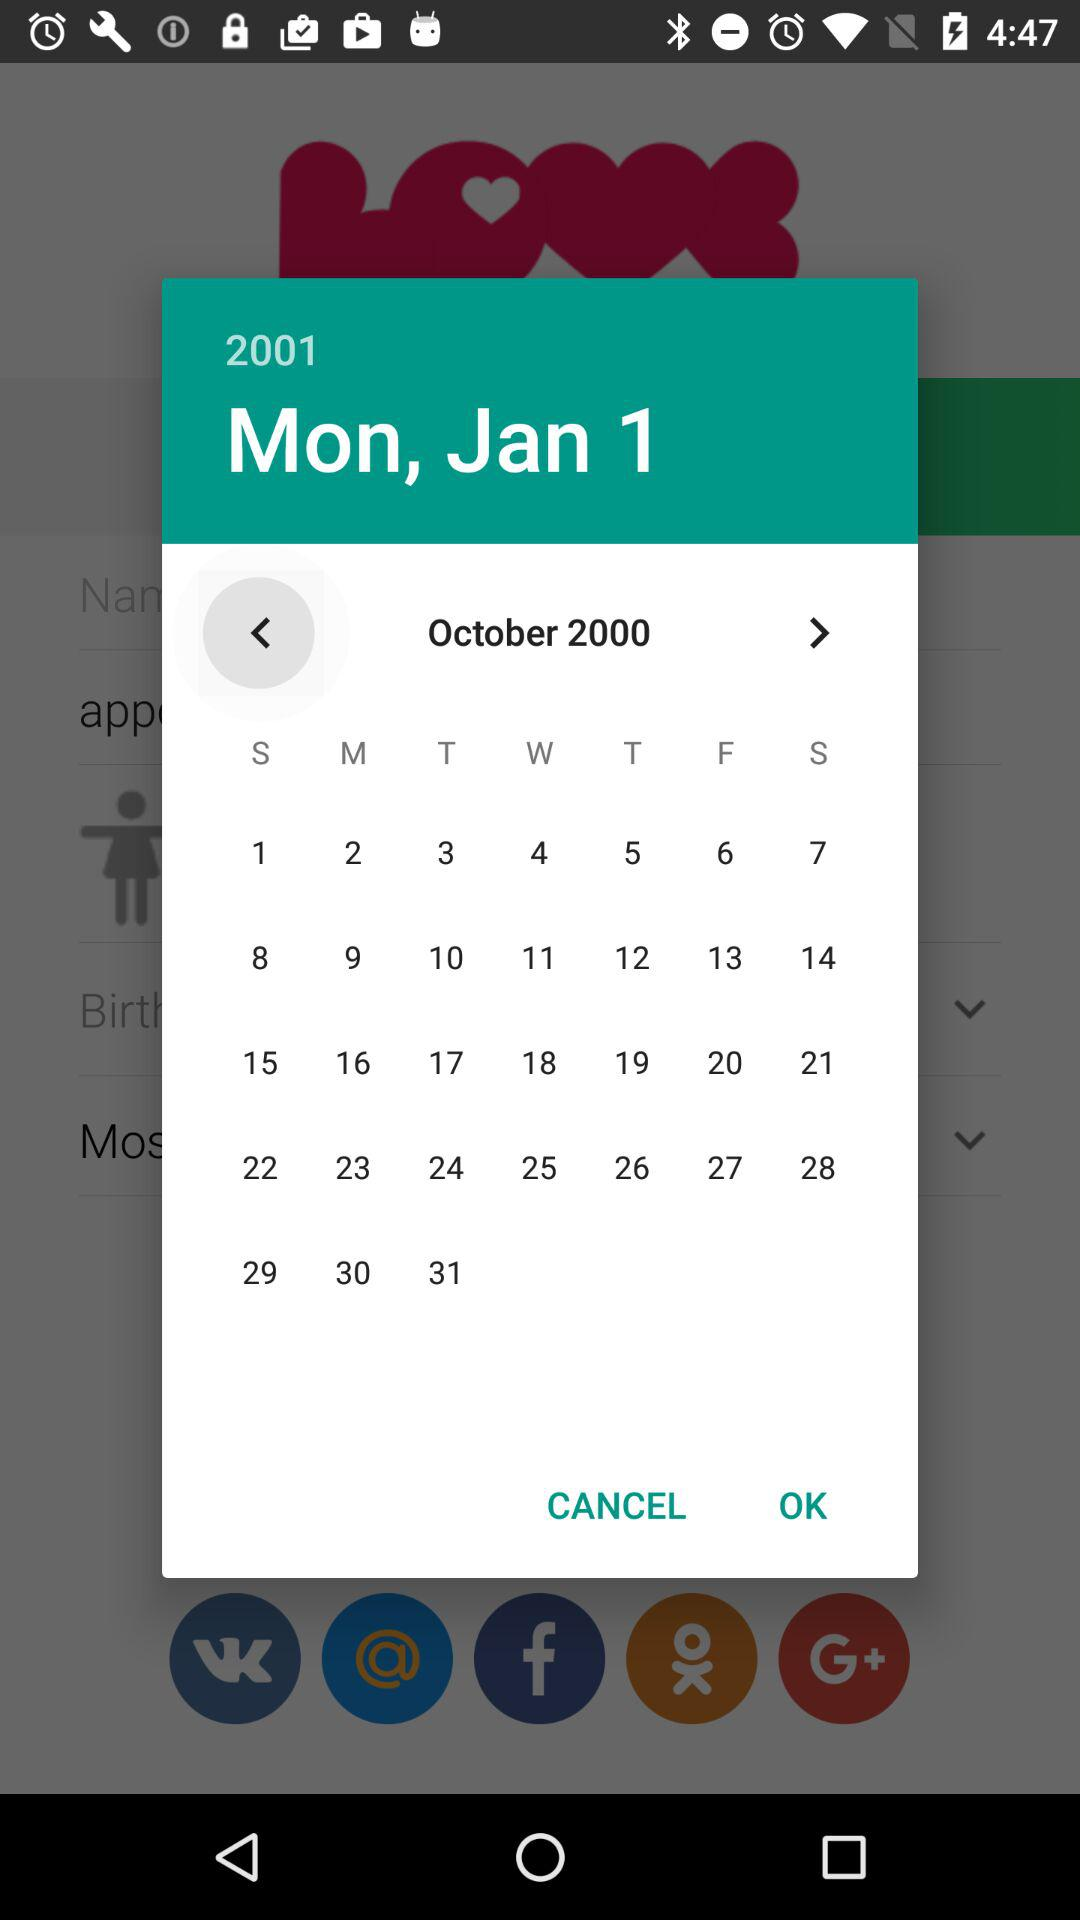What day falls on January 01, 2001? The day that falls on January 01, 2001 is a Monday. 